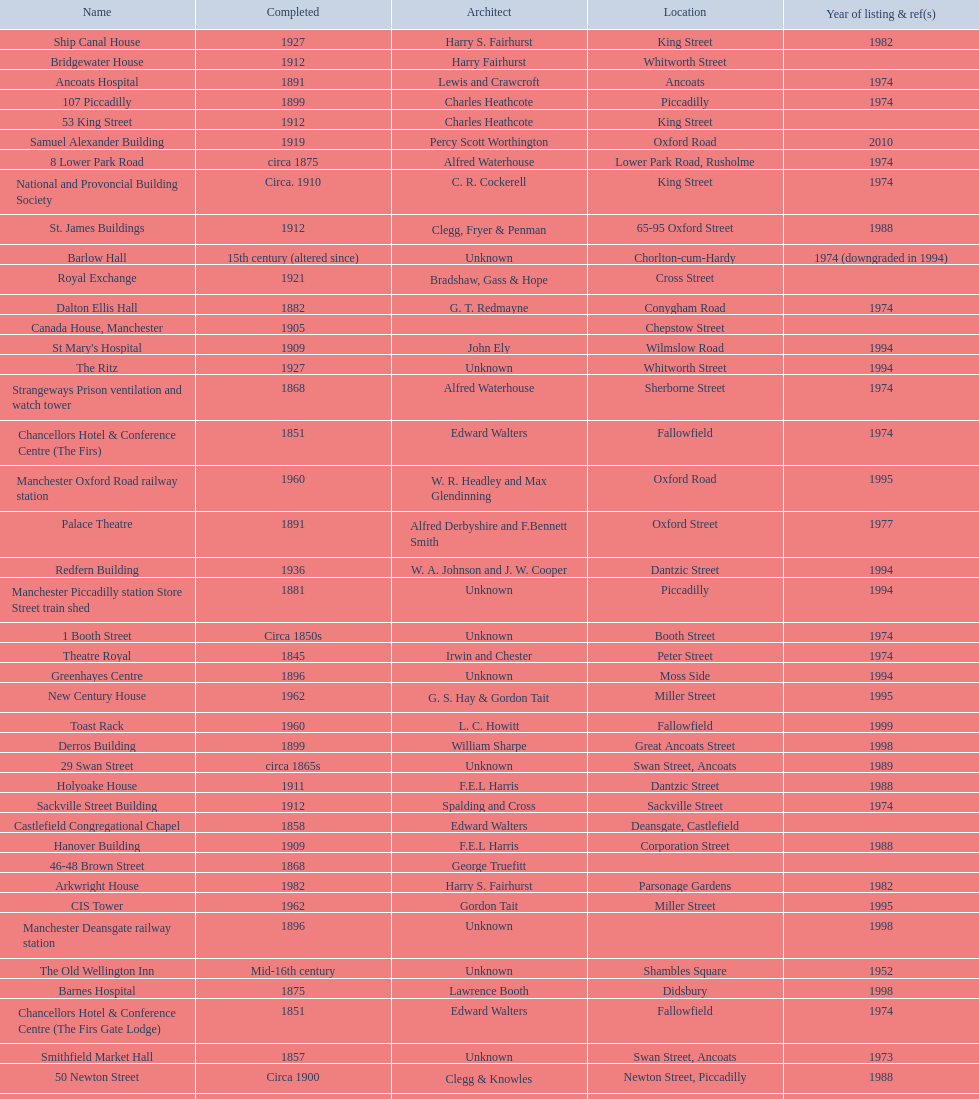How many buildings do not have an image listed? 11. 